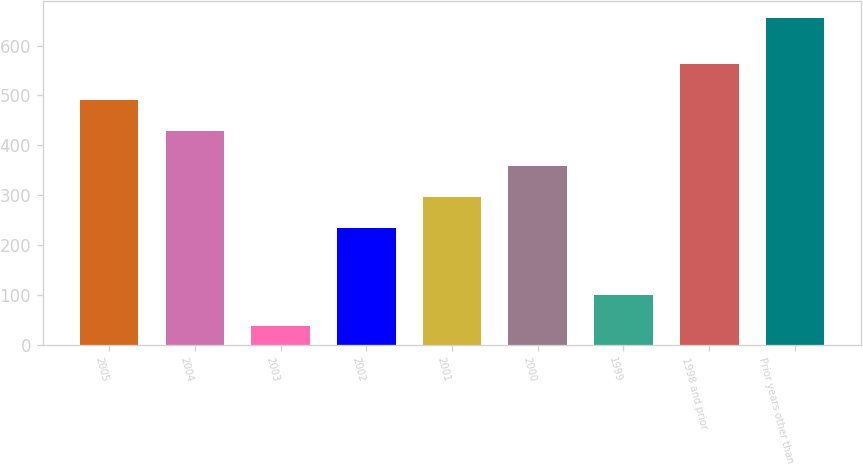<chart> <loc_0><loc_0><loc_500><loc_500><bar_chart><fcel>2005<fcel>2004<fcel>2003<fcel>2002<fcel>2001<fcel>2000<fcel>1999<fcel>1998 and prior<fcel>Prior years other than<nl><fcel>489.9<fcel>428<fcel>37<fcel>234<fcel>295.9<fcel>357.8<fcel>98.9<fcel>564<fcel>656<nl></chart> 